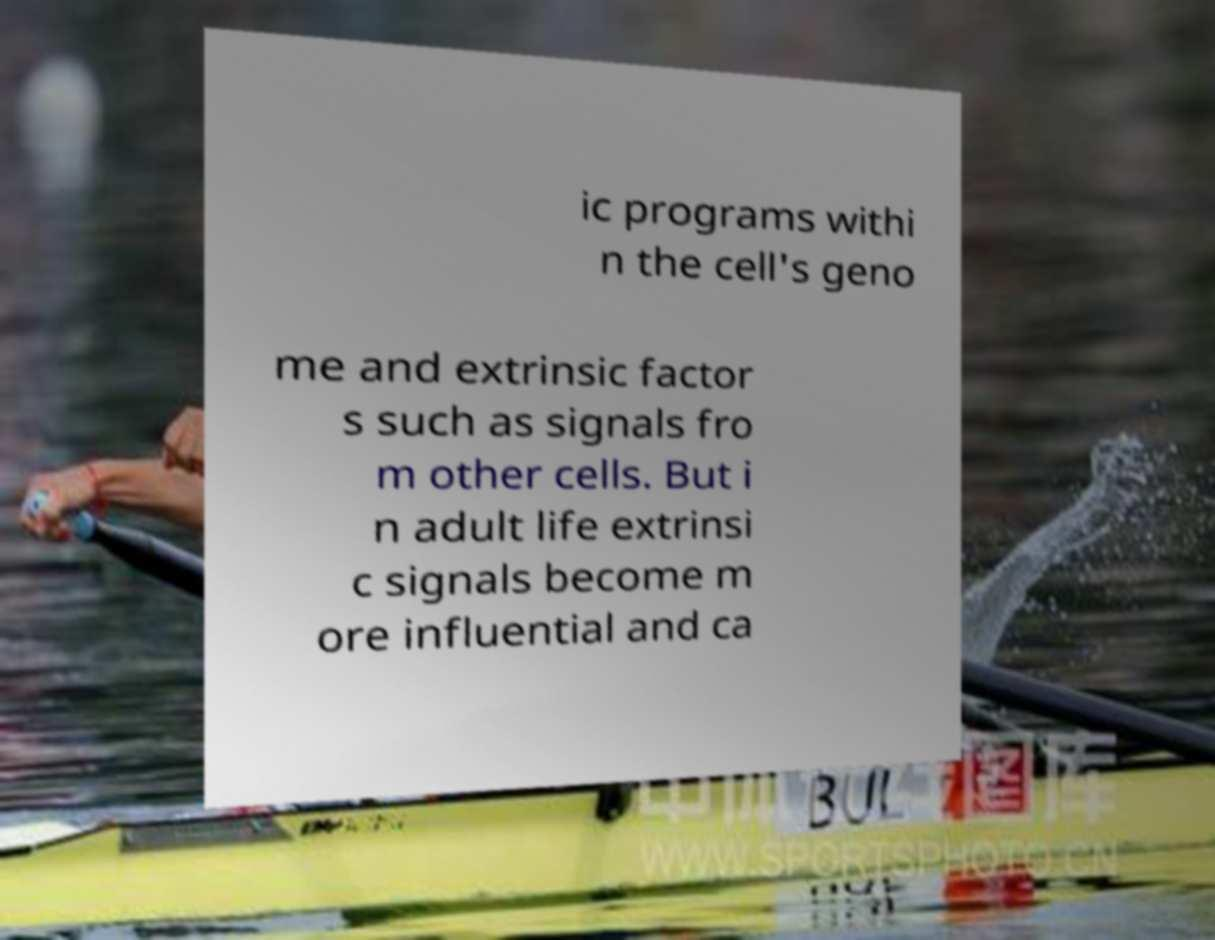I need the written content from this picture converted into text. Can you do that? ic programs withi n the cell's geno me and extrinsic factor s such as signals fro m other cells. But i n adult life extrinsi c signals become m ore influential and ca 